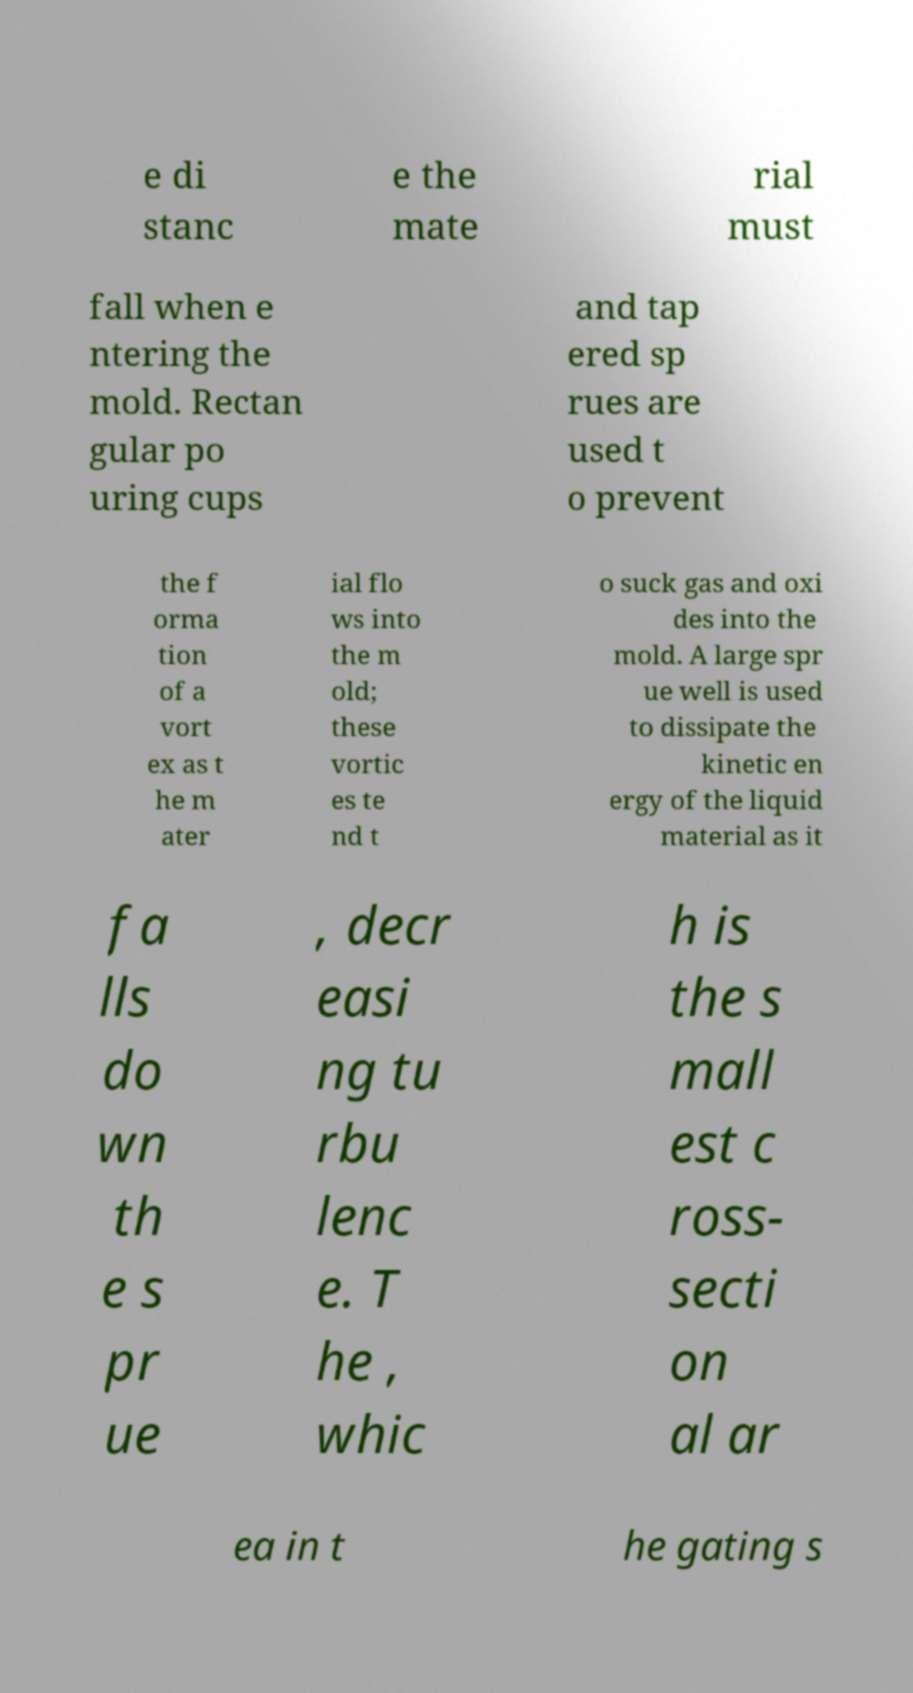Can you accurately transcribe the text from the provided image for me? e di stanc e the mate rial must fall when e ntering the mold. Rectan gular po uring cups and tap ered sp rues are used t o prevent the f orma tion of a vort ex as t he m ater ial flo ws into the m old; these vortic es te nd t o suck gas and oxi des into the mold. A large spr ue well is used to dissipate the kinetic en ergy of the liquid material as it fa lls do wn th e s pr ue , decr easi ng tu rbu lenc e. T he , whic h is the s mall est c ross- secti on al ar ea in t he gating s 